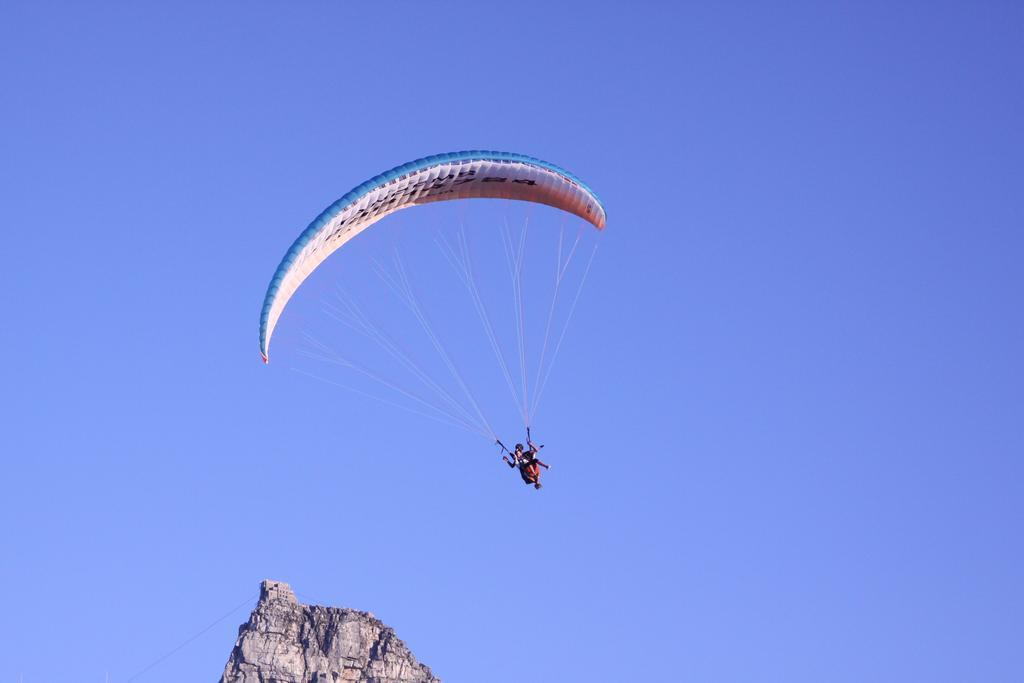What is the main feature of the landscape in the image? There is a hill in the image. What is happening at the top of the hill? There is a person wearing a parachute at the top of the hill. What type of suit is the lamp wearing in the image? There is no lamp or suit present in the image. What is the servant doing in the image? There is no servant present in the image. 